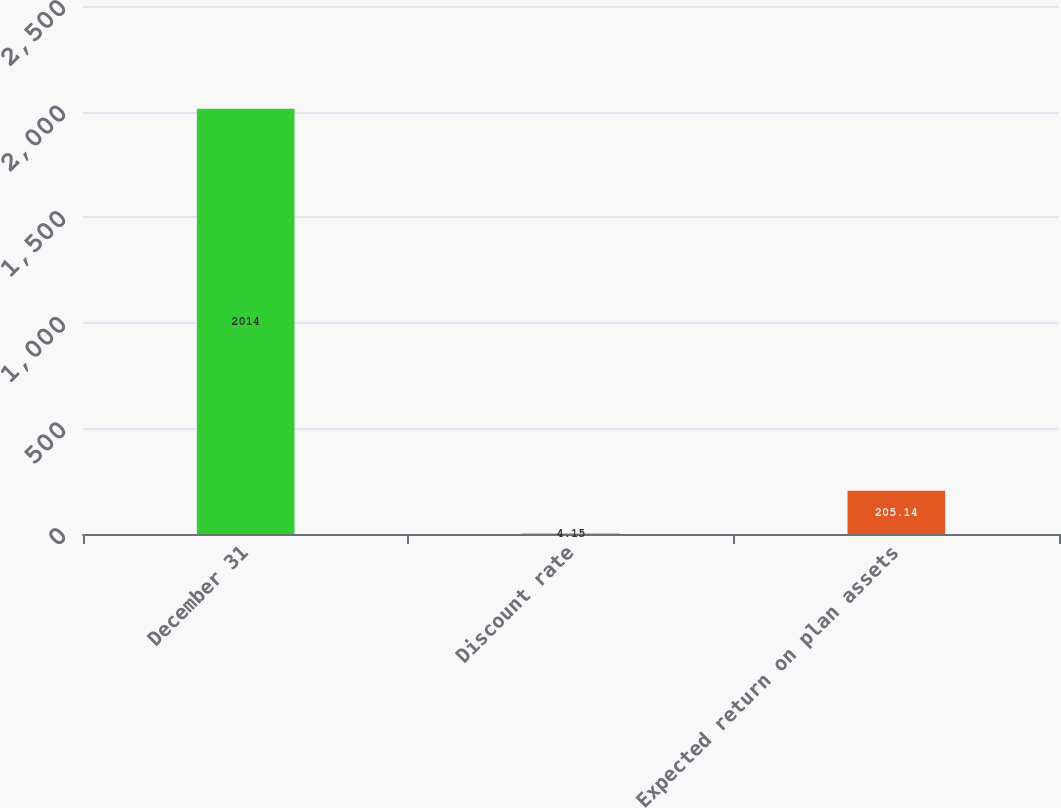Convert chart to OTSL. <chart><loc_0><loc_0><loc_500><loc_500><bar_chart><fcel>December 31<fcel>Discount rate<fcel>Expected return on plan assets<nl><fcel>2014<fcel>4.15<fcel>205.14<nl></chart> 